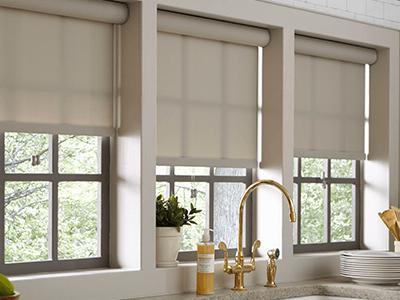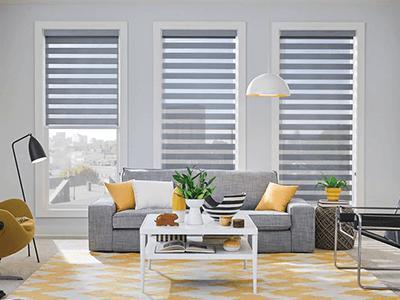The first image is the image on the left, the second image is the image on the right. Given the left and right images, does the statement "there are three windows with white trim and a sofa with pillows in front of it" hold true? Answer yes or no. Yes. The first image is the image on the left, the second image is the image on the right. For the images displayed, is the sentence "The left and right image contains a total of six blinds." factually correct? Answer yes or no. Yes. 